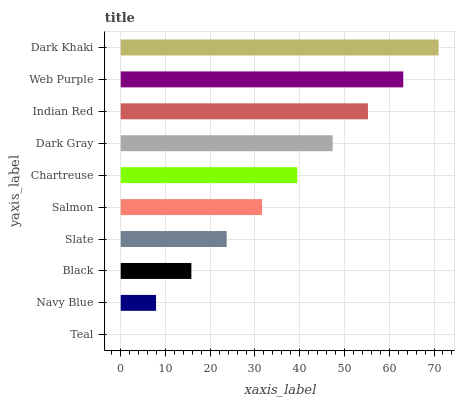Is Teal the minimum?
Answer yes or no. Yes. Is Dark Khaki the maximum?
Answer yes or no. Yes. Is Navy Blue the minimum?
Answer yes or no. No. Is Navy Blue the maximum?
Answer yes or no. No. Is Navy Blue greater than Teal?
Answer yes or no. Yes. Is Teal less than Navy Blue?
Answer yes or no. Yes. Is Teal greater than Navy Blue?
Answer yes or no. No. Is Navy Blue less than Teal?
Answer yes or no. No. Is Chartreuse the high median?
Answer yes or no. Yes. Is Salmon the low median?
Answer yes or no. Yes. Is Black the high median?
Answer yes or no. No. Is Web Purple the low median?
Answer yes or no. No. 